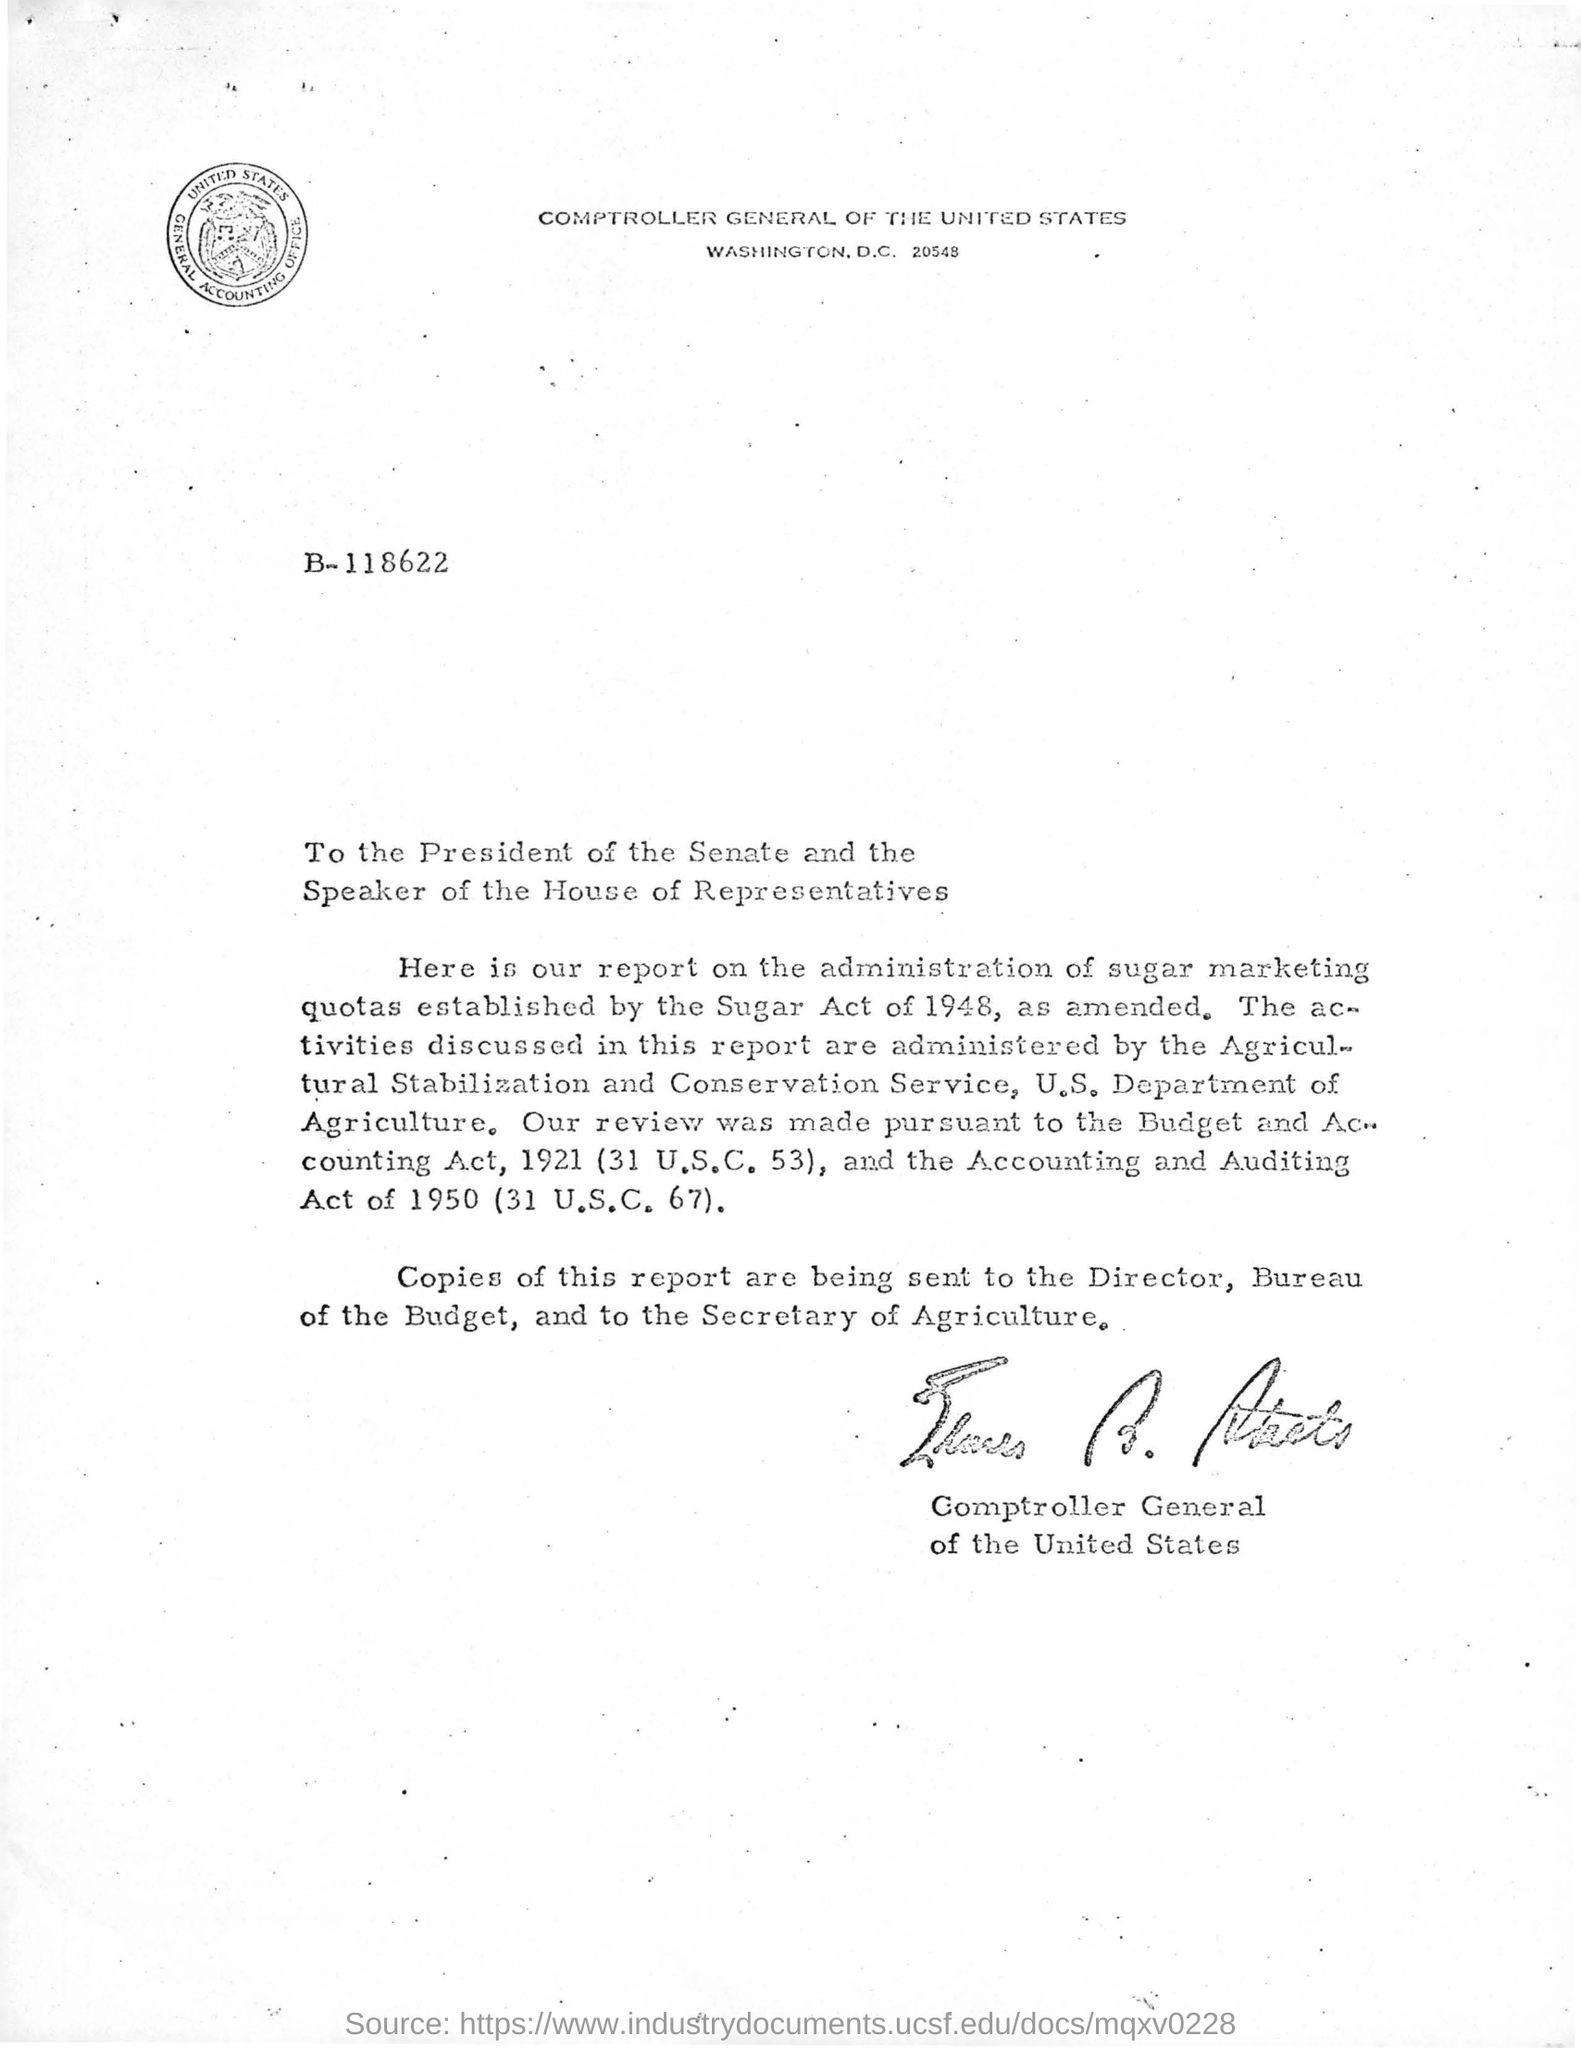Which department's secretary receive a copy of the letter?
Your answer should be very brief. Secretary of agriculture. Who administrated the activities discussed in this report ?
Provide a succinct answer. Agricultural Stabilization and Conservation Service. In which year the accounting and auditing act (31 U.S.C 67) came in to force?
Ensure brevity in your answer.  1950. Who signed the signature in this letter?
Offer a very short reply. Comptroller general of the united states. 